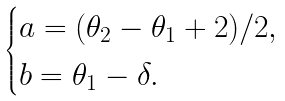Convert formula to latex. <formula><loc_0><loc_0><loc_500><loc_500>\begin{cases} a = ( \theta _ { 2 } - \theta _ { 1 } + 2 ) / 2 , \\ b = \theta _ { 1 } - \delta . \end{cases}</formula> 